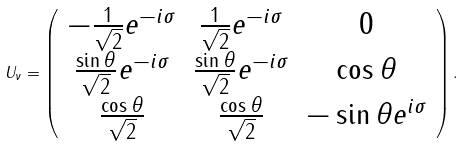Convert formula to latex. <formula><loc_0><loc_0><loc_500><loc_500>U _ { \nu } = \left ( \begin{array} { c c c } - \frac { 1 } { \sqrt { 2 } } e ^ { - i \sigma } & \frac { 1 } { \sqrt { 2 } } e ^ { - i \sigma } & 0 \\ \frac { \sin \theta } { \sqrt { 2 } } e ^ { - i \sigma } & \frac { \sin \theta } { \sqrt { 2 } } e ^ { - i \sigma } & \cos \theta \\ \frac { \cos \theta } { \sqrt { 2 } } & \frac { \cos \theta } { \sqrt { 2 } } & - \sin \theta e ^ { i \sigma } \end{array} \right ) .</formula> 